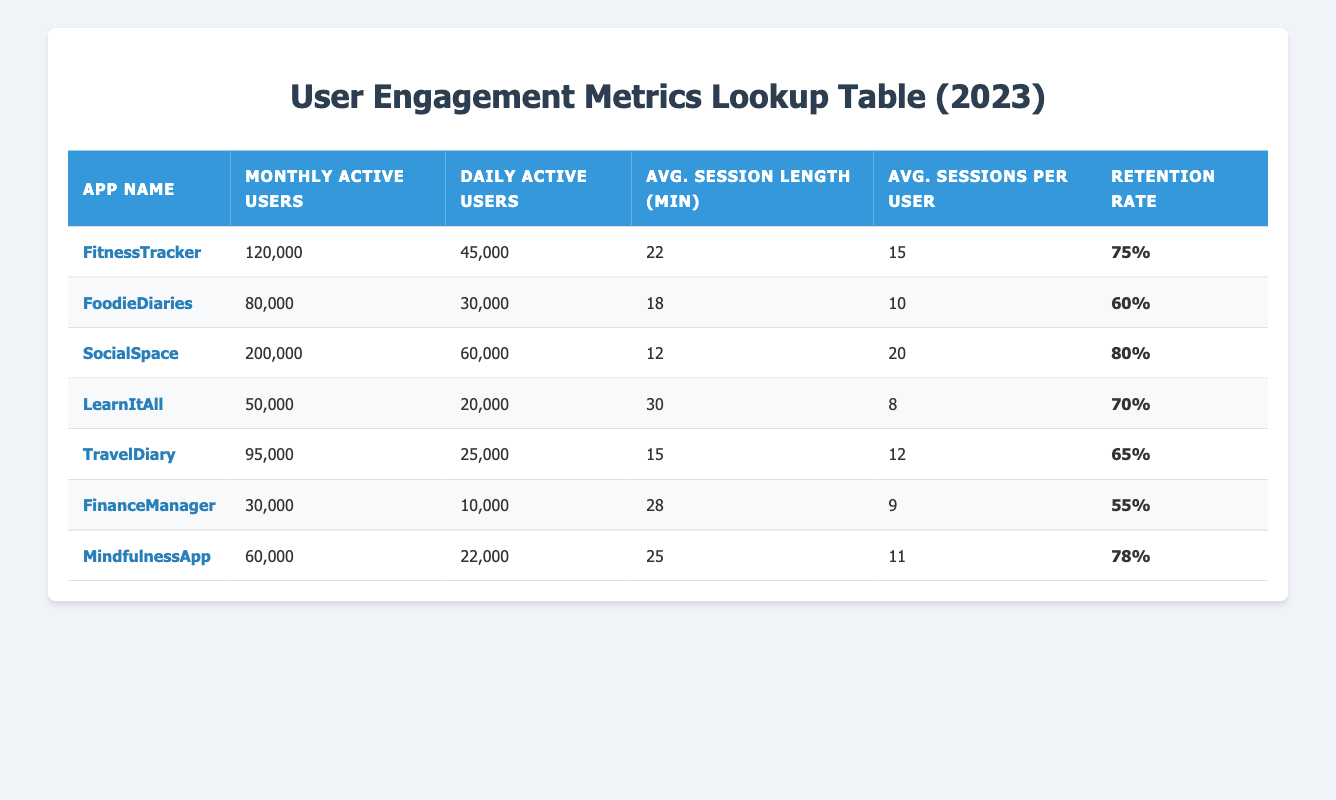What is the monthly active user count for SocialSpace? The table directly provides a row for SocialSpace, which lists its monthly active users as 200,000.
Answer: 200,000 Which app has the highest retention rate? Looking at the retention rates listed in the table, SocialSpace has the highest figure at 80%.
Answer: SocialSpace What is the average session length for LearnItAll? The table explicitly states that the average session length for LearnItAll is 30 minutes.
Answer: 30 What is the difference in daily active users between FitnessTracker and TravelDiary? For FitnessTracker, the daily active users are 45,000. For TravelDiary, the daily active users are 25,000. The difference is calculated as 45,000 - 25,000 = 20,000.
Answer: 20,000 Calculate the total number of monthly active users for all apps combined. The monthly active users for the apps are: 120,000 (FitnessTracker) + 80,000 (FoodieDiaries) + 200,000 (SocialSpace) + 50,000 (LearnItAll) + 95,000 (TravelDiary) + 30,000 (FinanceManager) + 60,000 (MindfulnessApp) = 635,000.
Answer: 635,000 Is the average session length for MindfulnessApp greater than 20 minutes? The average session length for MindfulnessApp is given as 25 minutes, which is greater than 20 minutes. Therefore, the statement is true.
Answer: Yes What percentage of users from FoodieDiaries are daily active users? FoodieDiaries has 30,000 daily active users out of 80,000 monthly active users. The percentage is calculated as (30,000 / 80,000) * 100 = 37.5%.
Answer: 37.5% Among the apps, which one has the lowest average sessions per user? The table indicates that LearnItAll has the lowest average sessions per user at 8.
Answer: LearnItAll If we combine the average session lengths of all apps, what is the following average session length? The session lengths for the apps are: 22, 18, 12, 30, 15, 28, and 25. First, we calculate the total: 22 + 18 + 12 + 30 + 15 + 28 + 25 = 150. There are 7 apps, so the average is 150 / 7 ≈ 21.43 minutes.
Answer: 21.43 